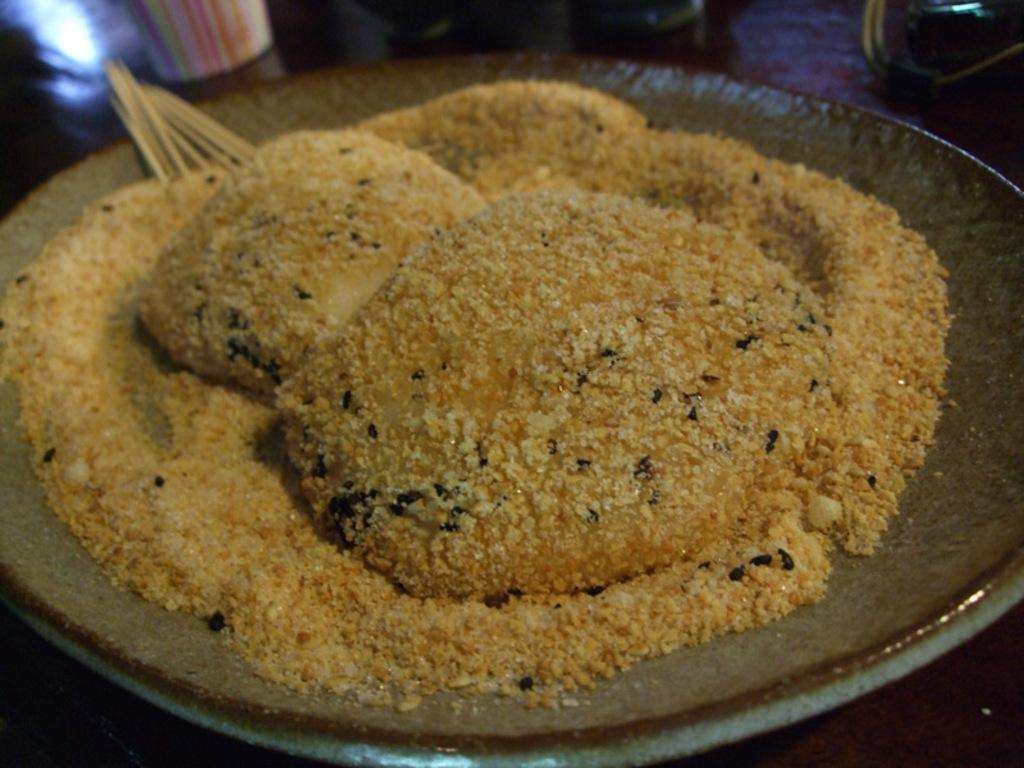What is the main subject of the image? The main subject of the image is a food item placed on a plate. Can you describe the objects in front of the plate? Unfortunately, the provided facts do not give any information about the objects in front of the plate. What is the scent of the owl in the image? There is no owl present in the image, so it is not possible to determine its scent. 